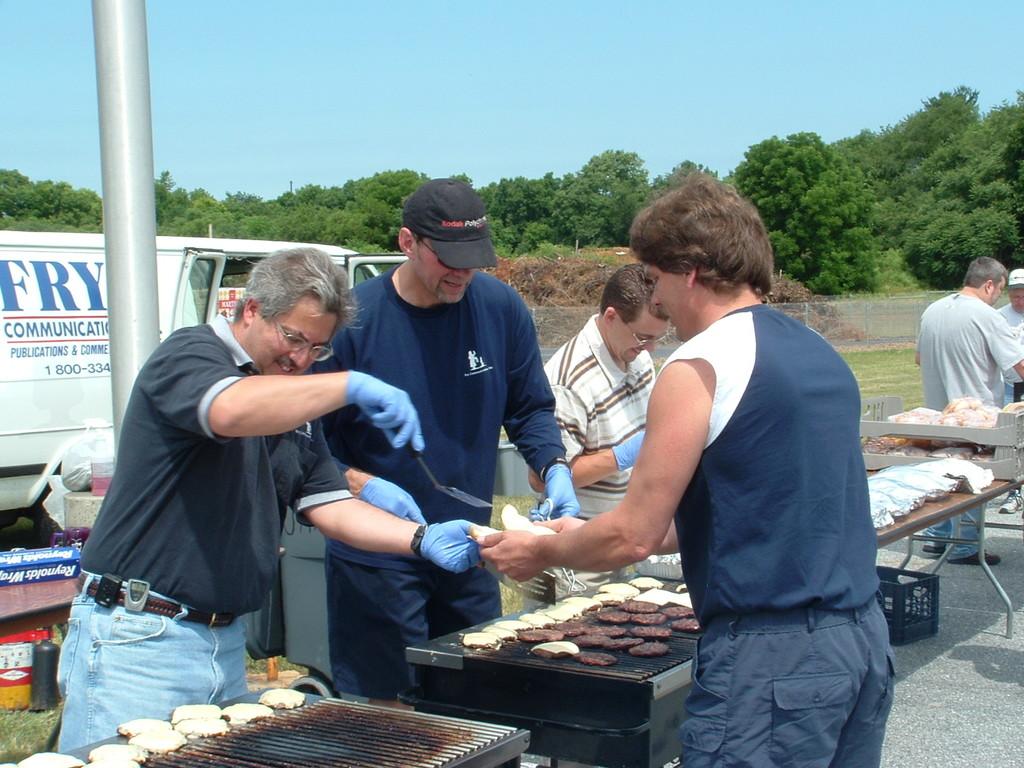What kind of business is the white van advertising?
Ensure brevity in your answer.  Communications. 